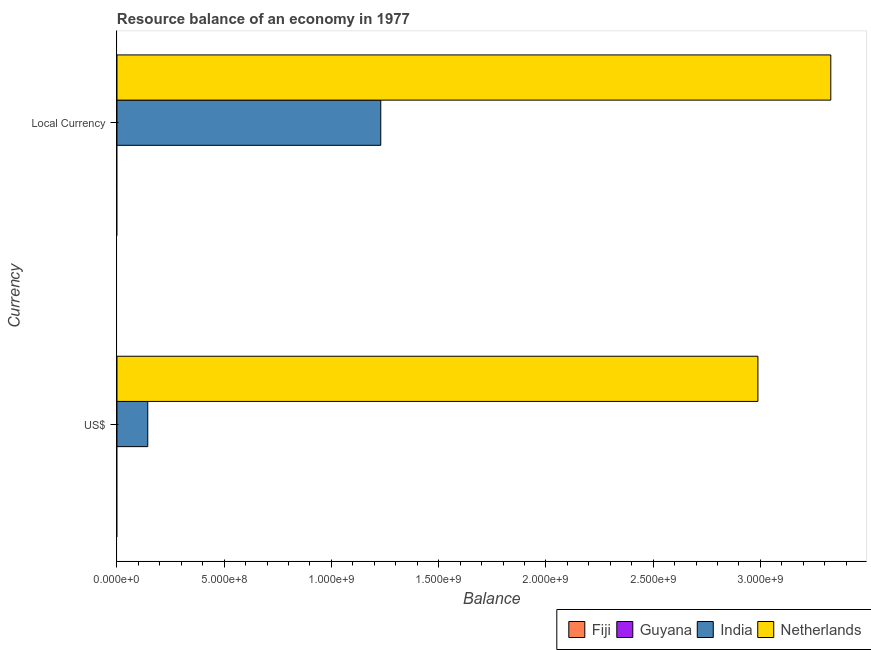How many groups of bars are there?
Keep it short and to the point. 2. Are the number of bars per tick equal to the number of legend labels?
Your response must be concise. No. Are the number of bars on each tick of the Y-axis equal?
Ensure brevity in your answer.  Yes. How many bars are there on the 2nd tick from the bottom?
Your answer should be compact. 2. What is the label of the 1st group of bars from the top?
Your answer should be very brief. Local Currency. Across all countries, what is the maximum resource balance in constant us$?
Your answer should be compact. 3.33e+09. Across all countries, what is the minimum resource balance in us$?
Your answer should be compact. 0. What is the total resource balance in constant us$ in the graph?
Offer a terse response. 4.56e+09. What is the difference between the resource balance in constant us$ in Netherlands and that in India?
Give a very brief answer. 2.10e+09. What is the difference between the resource balance in constant us$ in India and the resource balance in us$ in Guyana?
Ensure brevity in your answer.  1.23e+09. What is the average resource balance in us$ per country?
Your answer should be very brief. 7.83e+08. What is the difference between the resource balance in constant us$ and resource balance in us$ in India?
Your answer should be very brief. 1.09e+09. In how many countries, is the resource balance in constant us$ greater than 1000000000 units?
Ensure brevity in your answer.  2. What is the ratio of the resource balance in us$ in India to that in Netherlands?
Ensure brevity in your answer.  0.05. How many bars are there?
Offer a very short reply. 4. Are all the bars in the graph horizontal?
Ensure brevity in your answer.  Yes. Does the graph contain grids?
Offer a very short reply. No. What is the title of the graph?
Offer a terse response. Resource balance of an economy in 1977. What is the label or title of the X-axis?
Ensure brevity in your answer.  Balance. What is the label or title of the Y-axis?
Make the answer very short. Currency. What is the Balance in Fiji in US$?
Ensure brevity in your answer.  0. What is the Balance of India in US$?
Make the answer very short. 1.44e+08. What is the Balance in Netherlands in US$?
Provide a succinct answer. 2.99e+09. What is the Balance of Fiji in Local Currency?
Your response must be concise. 0. What is the Balance in Guyana in Local Currency?
Keep it short and to the point. 0. What is the Balance of India in Local Currency?
Keep it short and to the point. 1.23e+09. What is the Balance in Netherlands in Local Currency?
Give a very brief answer. 3.33e+09. Across all Currency, what is the maximum Balance in India?
Give a very brief answer. 1.23e+09. Across all Currency, what is the maximum Balance of Netherlands?
Your response must be concise. 3.33e+09. Across all Currency, what is the minimum Balance in India?
Ensure brevity in your answer.  1.44e+08. Across all Currency, what is the minimum Balance in Netherlands?
Keep it short and to the point. 2.99e+09. What is the total Balance of India in the graph?
Keep it short and to the point. 1.37e+09. What is the total Balance of Netherlands in the graph?
Offer a terse response. 6.32e+09. What is the difference between the Balance in India in US$ and that in Local Currency?
Give a very brief answer. -1.09e+09. What is the difference between the Balance of Netherlands in US$ and that in Local Currency?
Ensure brevity in your answer.  -3.40e+08. What is the difference between the Balance in India in US$ and the Balance in Netherlands in Local Currency?
Make the answer very short. -3.18e+09. What is the average Balance of Guyana per Currency?
Give a very brief answer. 0. What is the average Balance in India per Currency?
Give a very brief answer. 6.87e+08. What is the average Balance in Netherlands per Currency?
Your answer should be compact. 3.16e+09. What is the difference between the Balance in India and Balance in Netherlands in US$?
Offer a terse response. -2.84e+09. What is the difference between the Balance in India and Balance in Netherlands in Local Currency?
Provide a short and direct response. -2.10e+09. What is the ratio of the Balance in India in US$ to that in Local Currency?
Offer a very short reply. 0.12. What is the ratio of the Balance of Netherlands in US$ to that in Local Currency?
Give a very brief answer. 0.9. What is the difference between the highest and the second highest Balance in India?
Provide a succinct answer. 1.09e+09. What is the difference between the highest and the second highest Balance in Netherlands?
Make the answer very short. 3.40e+08. What is the difference between the highest and the lowest Balance in India?
Offer a terse response. 1.09e+09. What is the difference between the highest and the lowest Balance of Netherlands?
Your answer should be compact. 3.40e+08. 